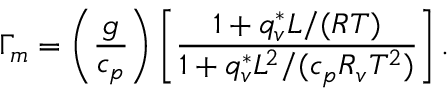<formula> <loc_0><loc_0><loc_500><loc_500>\Gamma _ { m } = \left ( \frac { g } { c _ { p } } \right ) \left [ \frac { 1 + q _ { v } ^ { * } L / ( R T ) } { 1 + q _ { v } ^ { * } L ^ { 2 } / ( c _ { p } R _ { v } T ^ { 2 } ) } \right ] .</formula> 